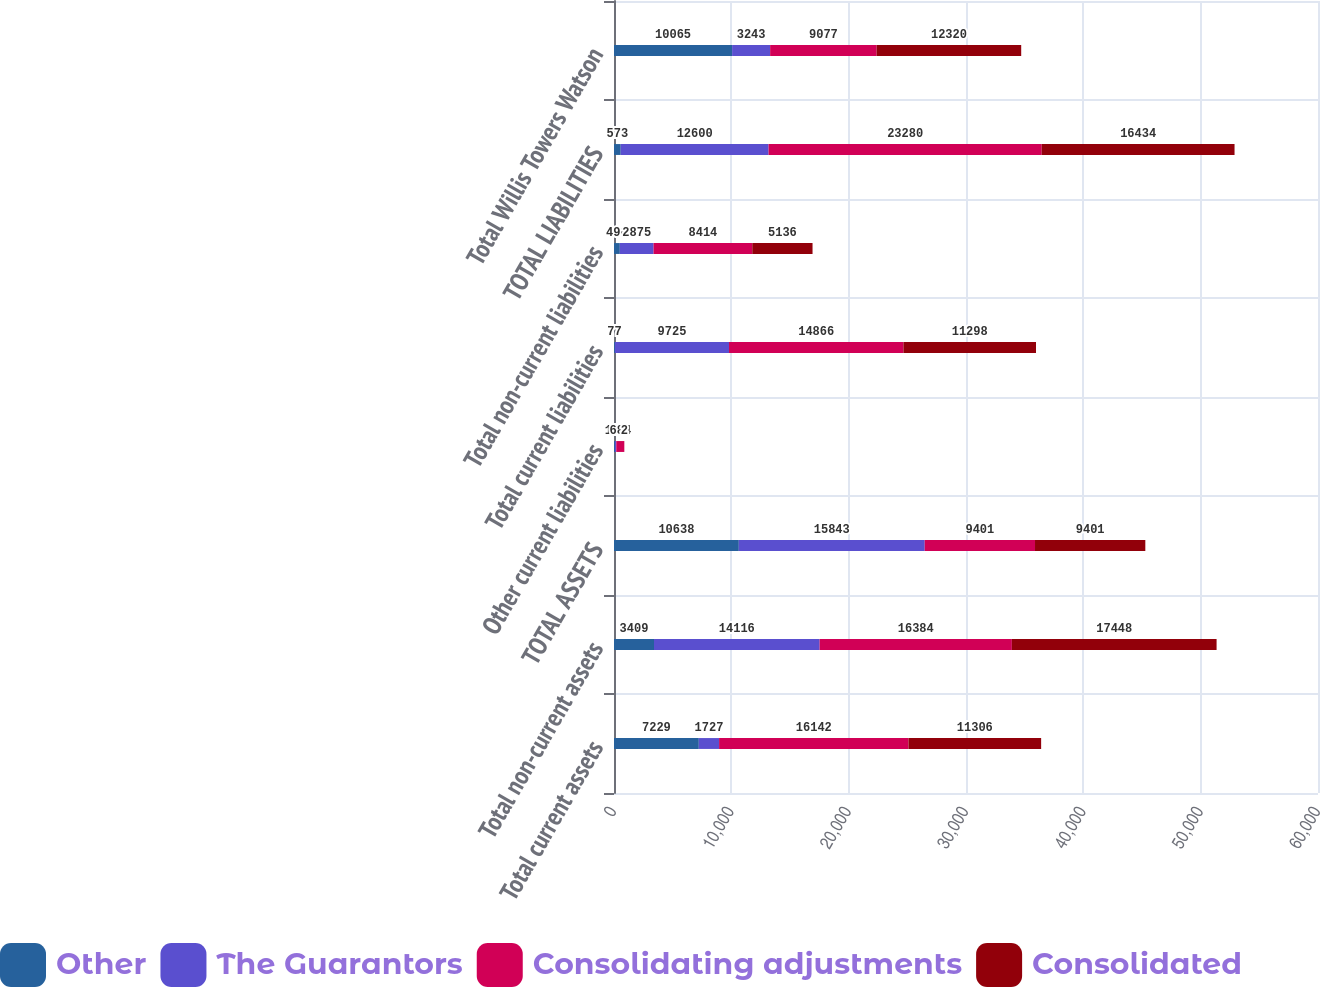Convert chart to OTSL. <chart><loc_0><loc_0><loc_500><loc_500><stacked_bar_chart><ecel><fcel>Total current assets<fcel>Total non-current assets<fcel>TOTAL ASSETS<fcel>Other current liabilities<fcel>Total current liabilities<fcel>Total non-current liabilities<fcel>TOTAL LIABILITIES<fcel>Total Willis Towers Watson<nl><fcel>Other<fcel>7229<fcel>3409<fcel>10638<fcel>77<fcel>77<fcel>496<fcel>573<fcel>10065<nl><fcel>The Guarantors<fcel>1727<fcel>14116<fcel>15843<fcel>117<fcel>9725<fcel>2875<fcel>12600<fcel>3243<nl><fcel>Consolidating adjustments<fcel>16142<fcel>16384<fcel>9401<fcel>684<fcel>14866<fcel>8414<fcel>23280<fcel>9077<nl><fcel>Consolidated<fcel>11306<fcel>17448<fcel>9401<fcel>2<fcel>11298<fcel>5136<fcel>16434<fcel>12320<nl></chart> 